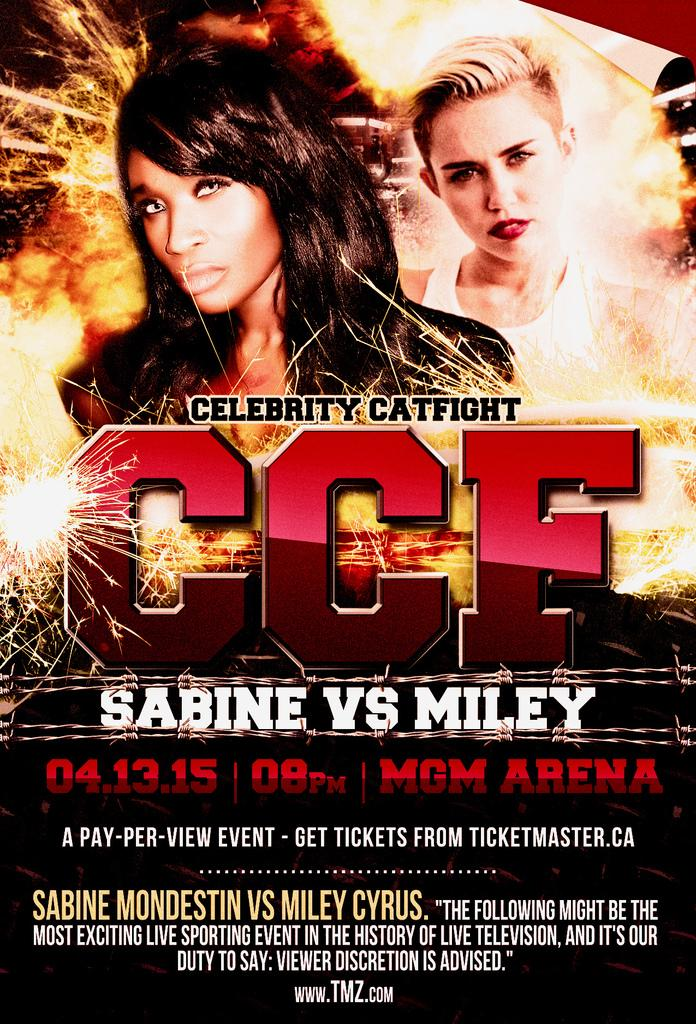<image>
Create a compact narrative representing the image presented. Poster for Sabine vs Miley that is on pay per view. 